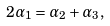Convert formula to latex. <formula><loc_0><loc_0><loc_500><loc_500>2 \alpha _ { 1 } = \alpha _ { 2 } + \alpha _ { 3 } ,</formula> 